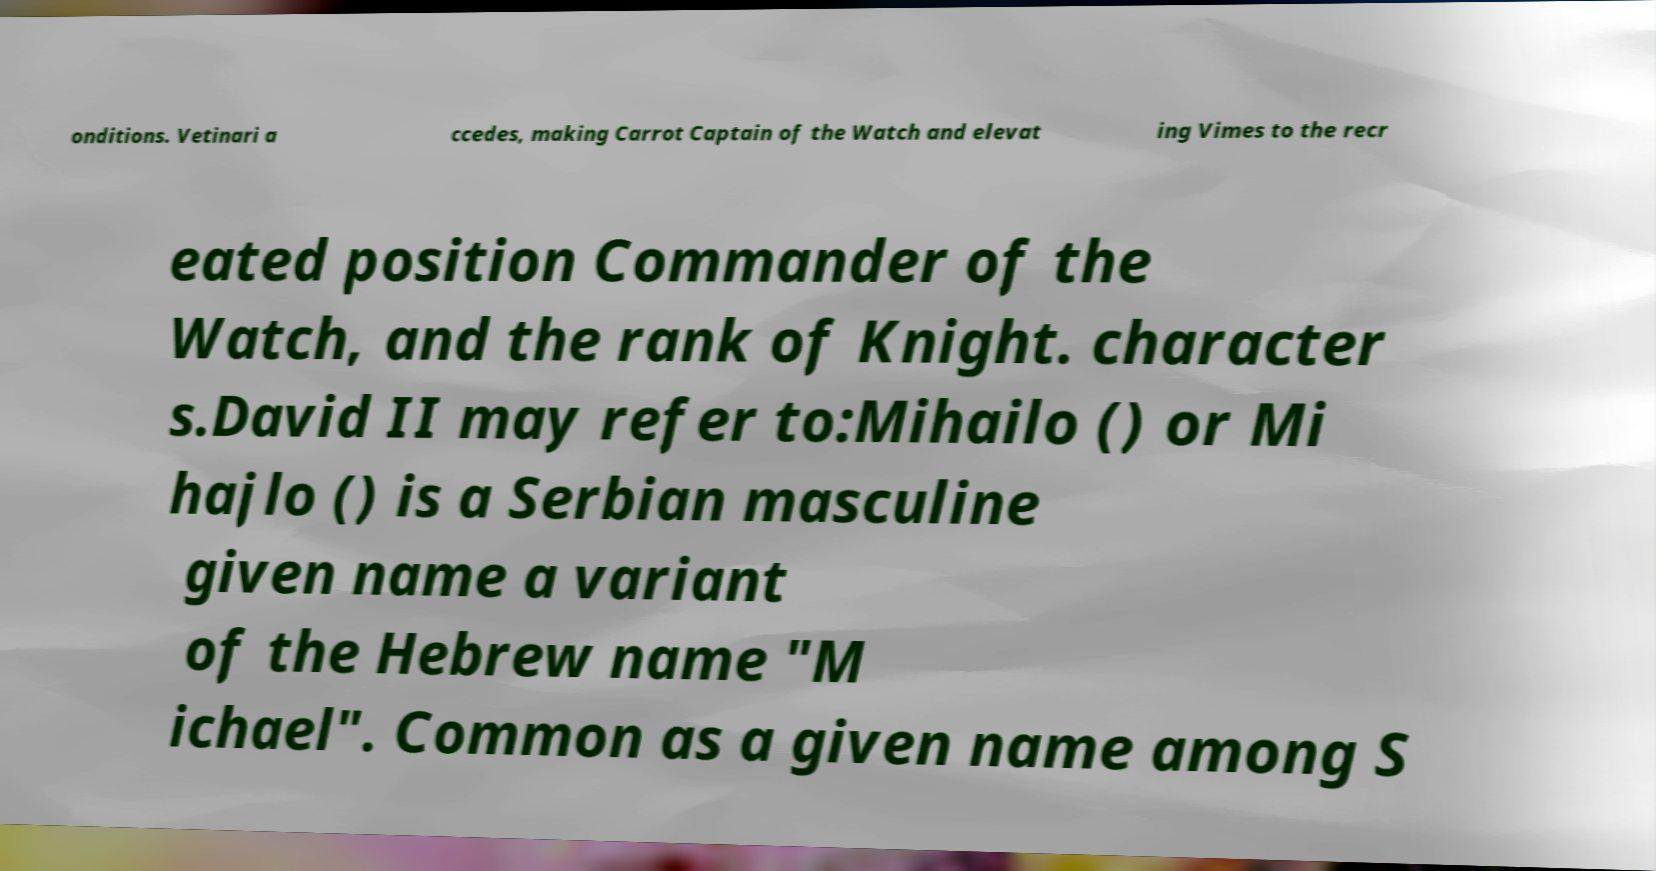What messages or text are displayed in this image? I need them in a readable, typed format. onditions. Vetinari a ccedes, making Carrot Captain of the Watch and elevat ing Vimes to the recr eated position Commander of the Watch, and the rank of Knight. character s.David II may refer to:Mihailo () or Mi hajlo () is a Serbian masculine given name a variant of the Hebrew name "M ichael". Common as a given name among S 